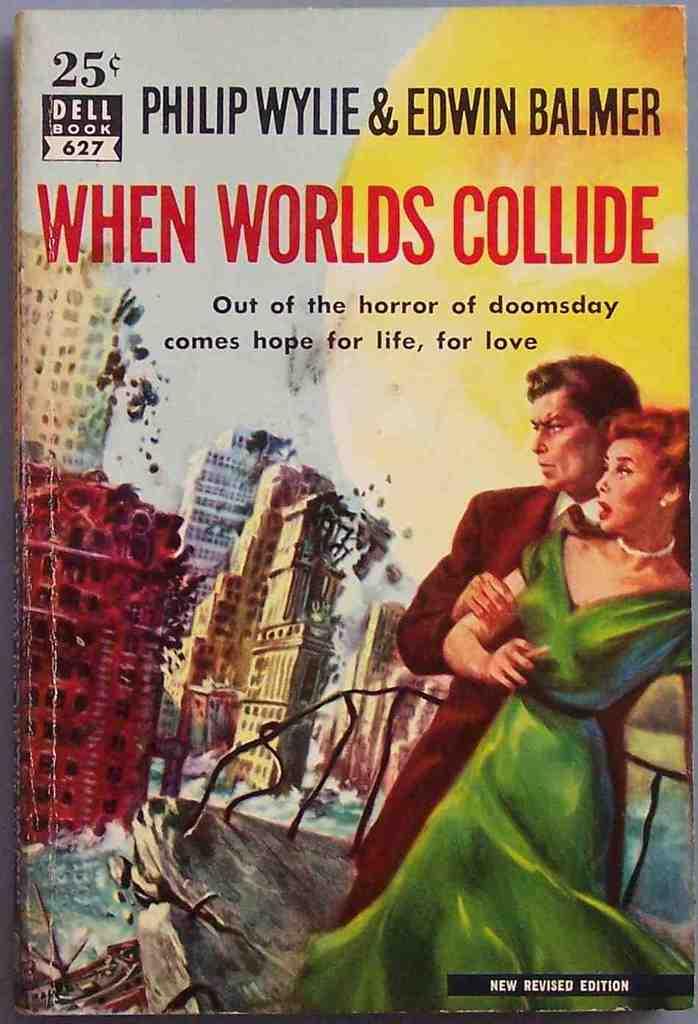How much was this book when it was published?
Your answer should be compact. 25 cents. Who is the publisher of the book?
Your answer should be compact. Dell. 